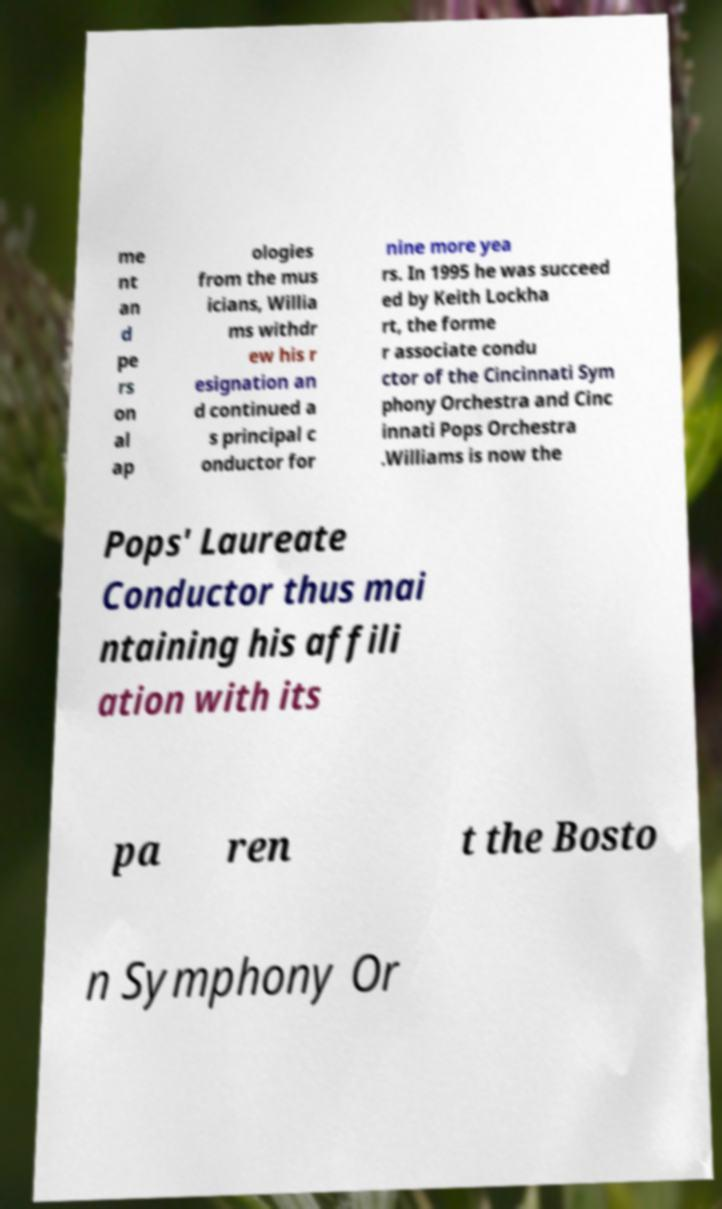I need the written content from this picture converted into text. Can you do that? me nt an d pe rs on al ap ologies from the mus icians, Willia ms withdr ew his r esignation an d continued a s principal c onductor for nine more yea rs. In 1995 he was succeed ed by Keith Lockha rt, the forme r associate condu ctor of the Cincinnati Sym phony Orchestra and Cinc innati Pops Orchestra .Williams is now the Pops' Laureate Conductor thus mai ntaining his affili ation with its pa ren t the Bosto n Symphony Or 